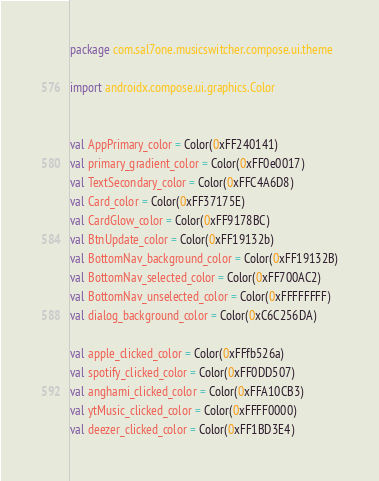Convert code to text. <code><loc_0><loc_0><loc_500><loc_500><_Kotlin_>package com.sal7one.musicswitcher.compose.ui.theme

import androidx.compose.ui.graphics.Color


val AppPrimary_color = Color(0xFF240141)
val primary_gradient_color = Color(0xFF0e0017)
val TextSecondary_color = Color(0xFFC4A6D8)
val Card_color = Color(0xFF37175E)
val CardGlow_color = Color(0xFF9178BC)
val BtnUpdate_color = Color(0xFF19132b)
val BottomNav_background_color = Color(0xFF19132B)
val BottomNav_selected_color = Color(0xFF700AC2)
val BottomNav_unselected_color = Color(0xFFFFFFFF)
val dialog_background_color = Color(0xC6C256DA)

val apple_clicked_color = Color(0xFFfb526a)
val spotify_clicked_color = Color(0xFF0DD507)
val anghami_clicked_color = Color(0xFFA10CB3)
val ytMusic_clicked_color = Color(0xFFFF0000)
val deezer_clicked_color = Color(0xFF1BD3E4)
</code> 